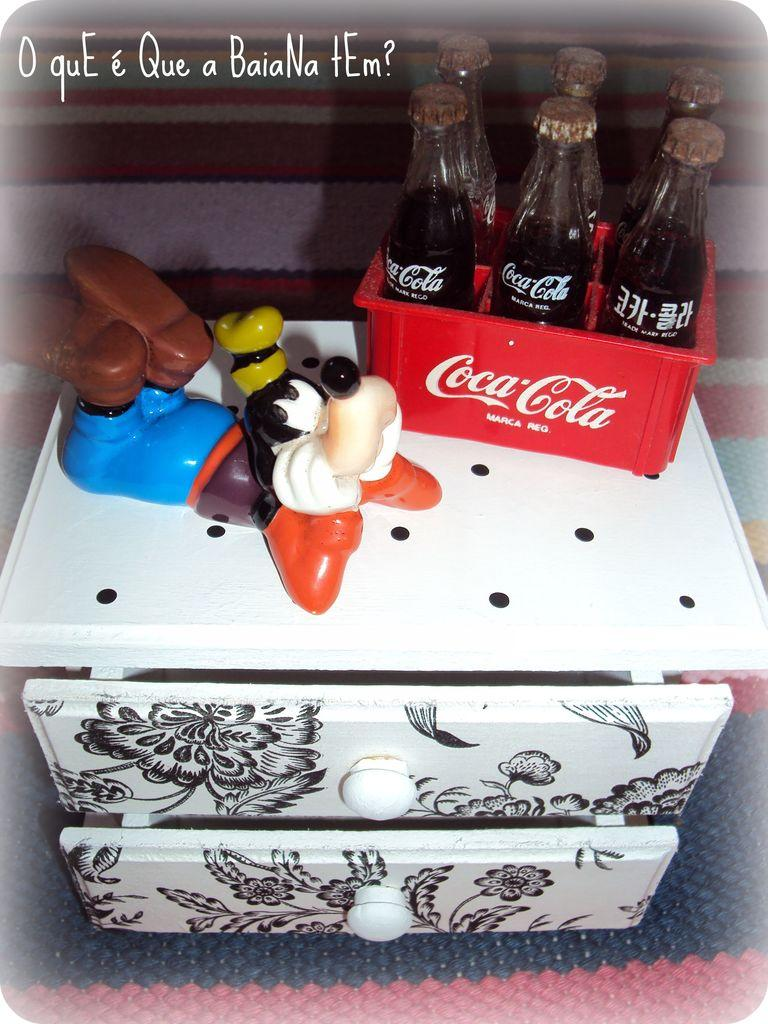How many coca cola bottles are visible in the image? There are six coca cola bottles in the image. Where are the coca cola bottles located? The coca cola bottles are in a box. What other object can be seen in the image? There is a toy on a table in the image. How many songs can be heard playing in the background of the image? There is no information about any songs playing in the background of the image. 